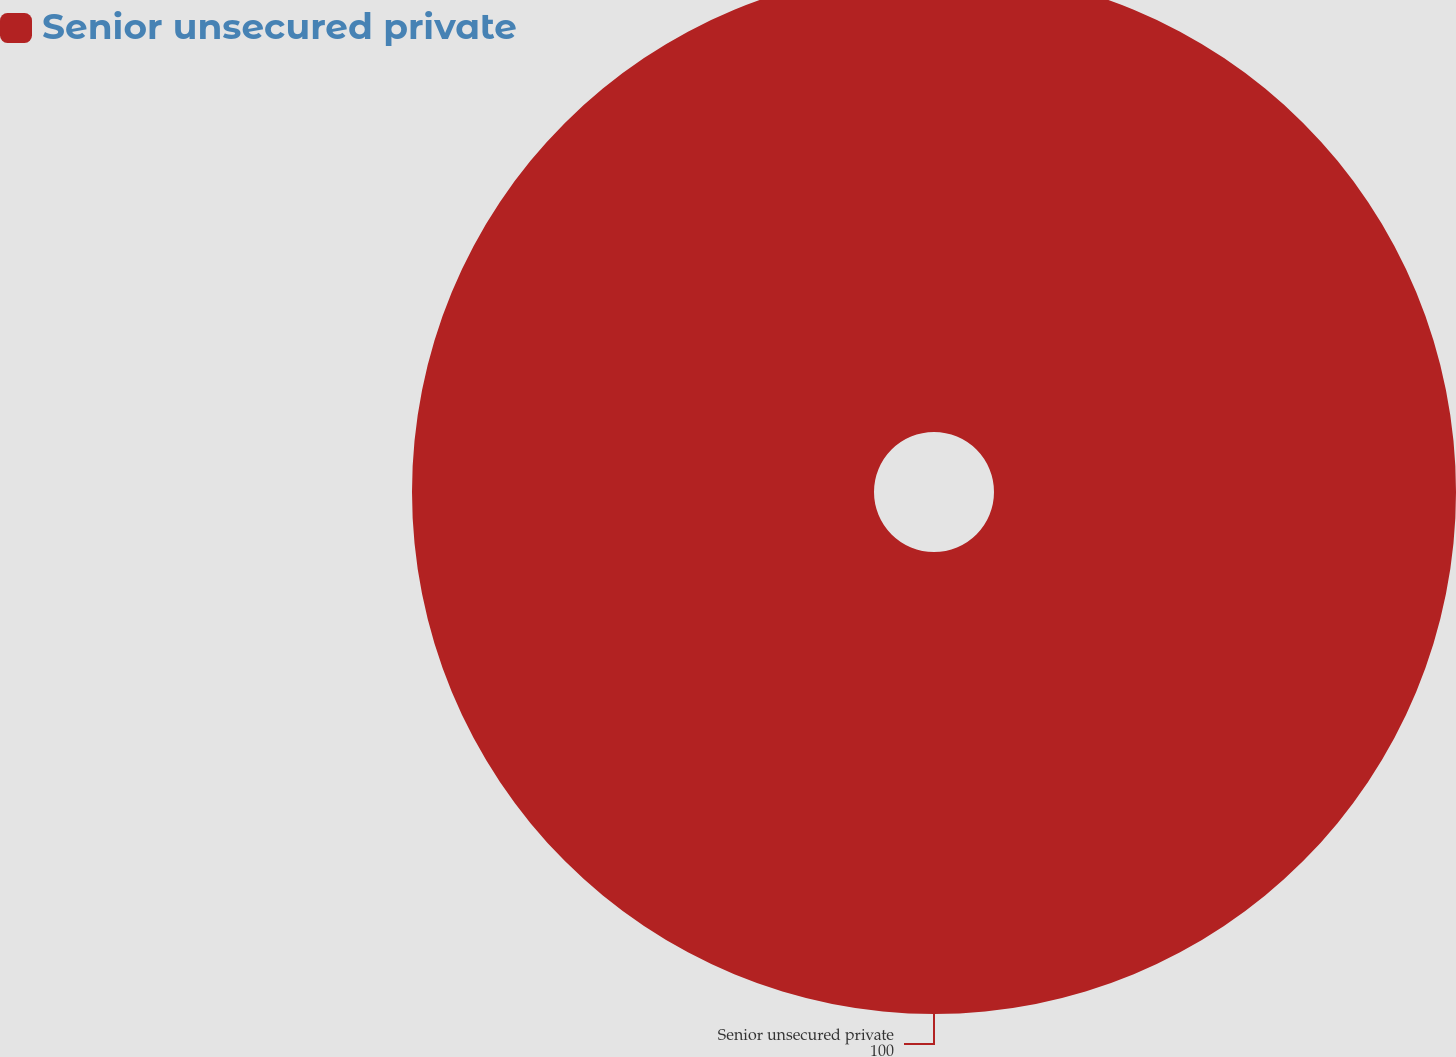Convert chart. <chart><loc_0><loc_0><loc_500><loc_500><pie_chart><fcel>Senior unsecured private<nl><fcel>100.0%<nl></chart> 